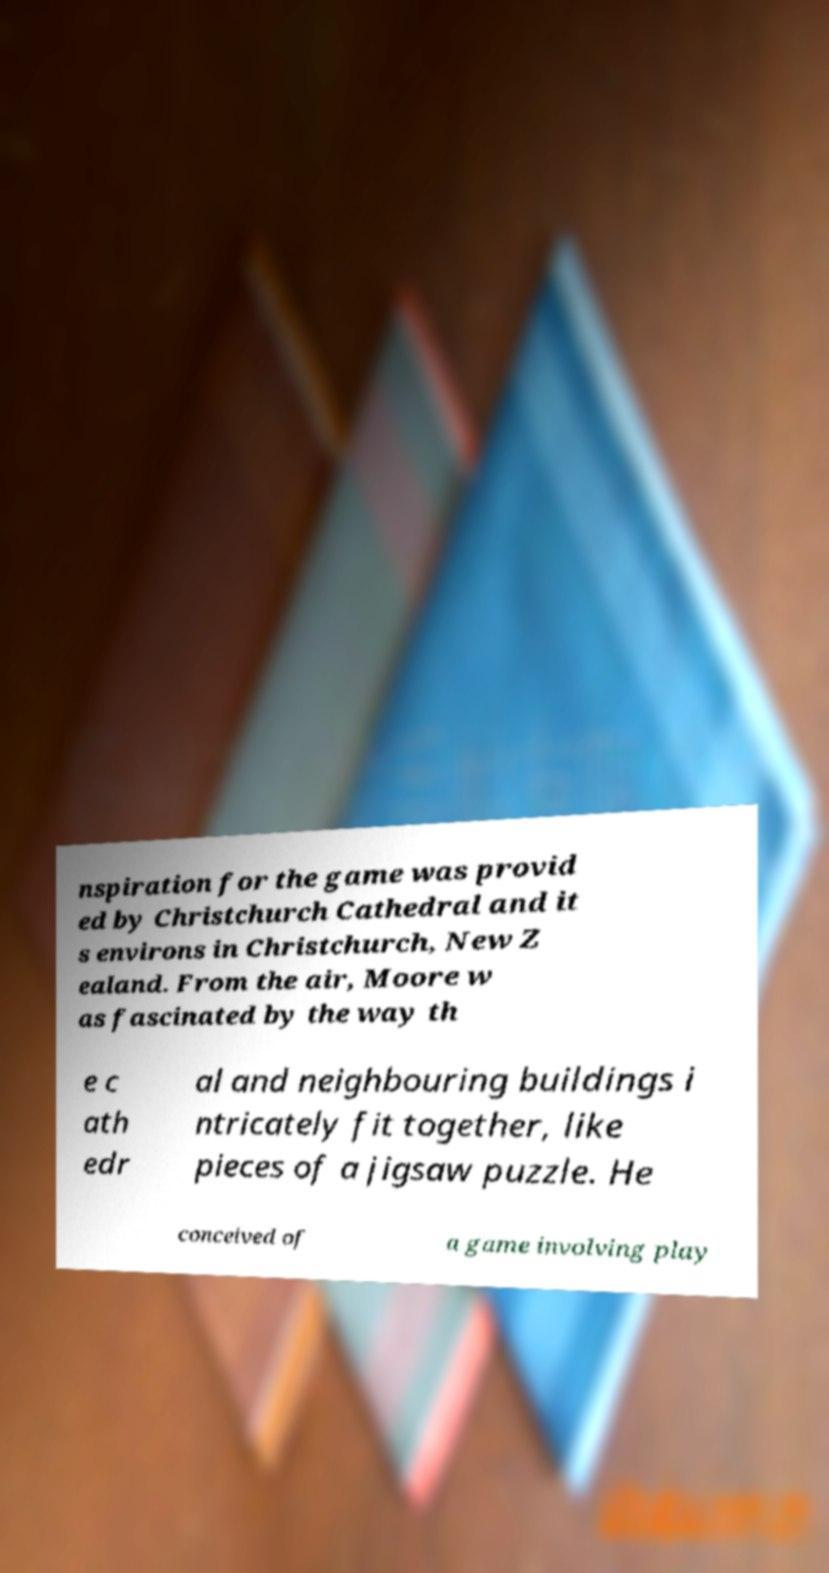There's text embedded in this image that I need extracted. Can you transcribe it verbatim? nspiration for the game was provid ed by Christchurch Cathedral and it s environs in Christchurch, New Z ealand. From the air, Moore w as fascinated by the way th e c ath edr al and neighbouring buildings i ntricately fit together, like pieces of a jigsaw puzzle. He conceived of a game involving play 